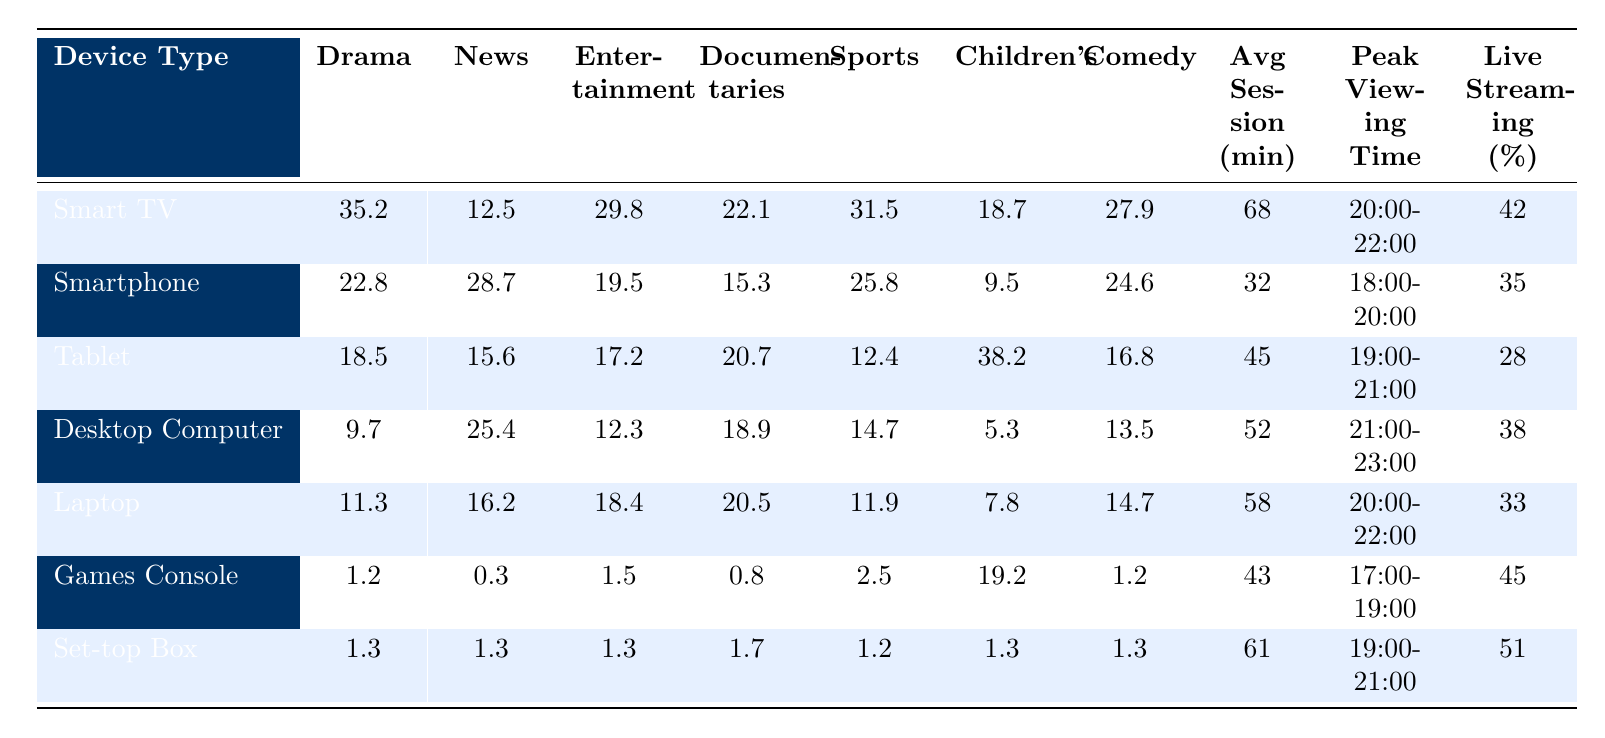What device type has the highest percentage of live streaming? By looking at the "Percentage of Live Streaming" column, the highest value is 51% for the Set-top Box.
Answer: Set-top Box Which content category has the highest average session duration on Smart TV? Referring to the "Avg Session (min)" column for Smart TV, the highest average session duration is 68 minutes, associated with the Drama category.
Answer: Drama How does the average session duration on a Smartphone compare to a Tablet? The average session duration for a Smartphone is 32 minutes, while for a Tablet it is 45 minutes. The difference is 45 - 32 = 13 minutes, meaning the Tablet has a longer session duration.
Answer: Tablet has 13 minutes longer Is the percentage of live streaming higher for Games Consoles or Desktop Computers? The percentage of live streaming for Games Consoles is 45%, while for Desktop Computers it is 38%. Since 45% is greater than 38%, Games Consoles have a higher percentage.
Answer: Yes, Games Consoles What is the total percentage of live streaming for all devices combined? To find the total percentage of live streaming, we add all values: 42 + 35 + 28 + 38 + 33 + 45 + 51 = 272, so the total is 272%.
Answer: 272% Which device type is the least popular for Drama content? By checking the "Drama" column, Games Console has the lowest value at 1.2, making it the least popular for Drama content.
Answer: Games Console Which content category is the most popular on Tablets based on percentage? Referring to the Tablet row, the highest percentage is for Children's content at 38.2%.
Answer: Children's How many content categories have an average session duration greater than 60 minutes on Smart TVs? The average session duration for Smart TVs is 68 minutes. Since only Drama exceeds this threshold in the Smart TV row, there is 1 category larger than 60 minutes.
Answer: 1 What is the average percentage of live streaming for devices with the highest viewership in the Comedy category? The highest percentages for Comedy come from Smart TV (27.9) and Smartphone (24.6). The average thus is (27.9 + 24.6) / 2 = 26.25%.
Answer: 26.25% Which content category has the highest overall popularity across all devices? By summing the percentages for each category: Drama(35.2+22.8+18.5+9.7+11.3+1.2+1.3), News(12.5+28.7+15.6+25.4+16.2+0.3+1.3), Entertainment(29.8+19.5+17.2+12.3+18.4+1.5+1.3), Documentaries(22.1+15.3+20.7+18.9+20.5+0.8+1.7), Sports(31.5+25.8+12.4+14.7+11.9+2.5+1.2), Children's(18.7+9.5+38.2+5.3+7.8+19.2+1.3), Comedy(27.9+24.6+16.8+13.5+14.7+1.2+1.3), we find Drama with the highest sum of 139.9.
Answer: Drama 